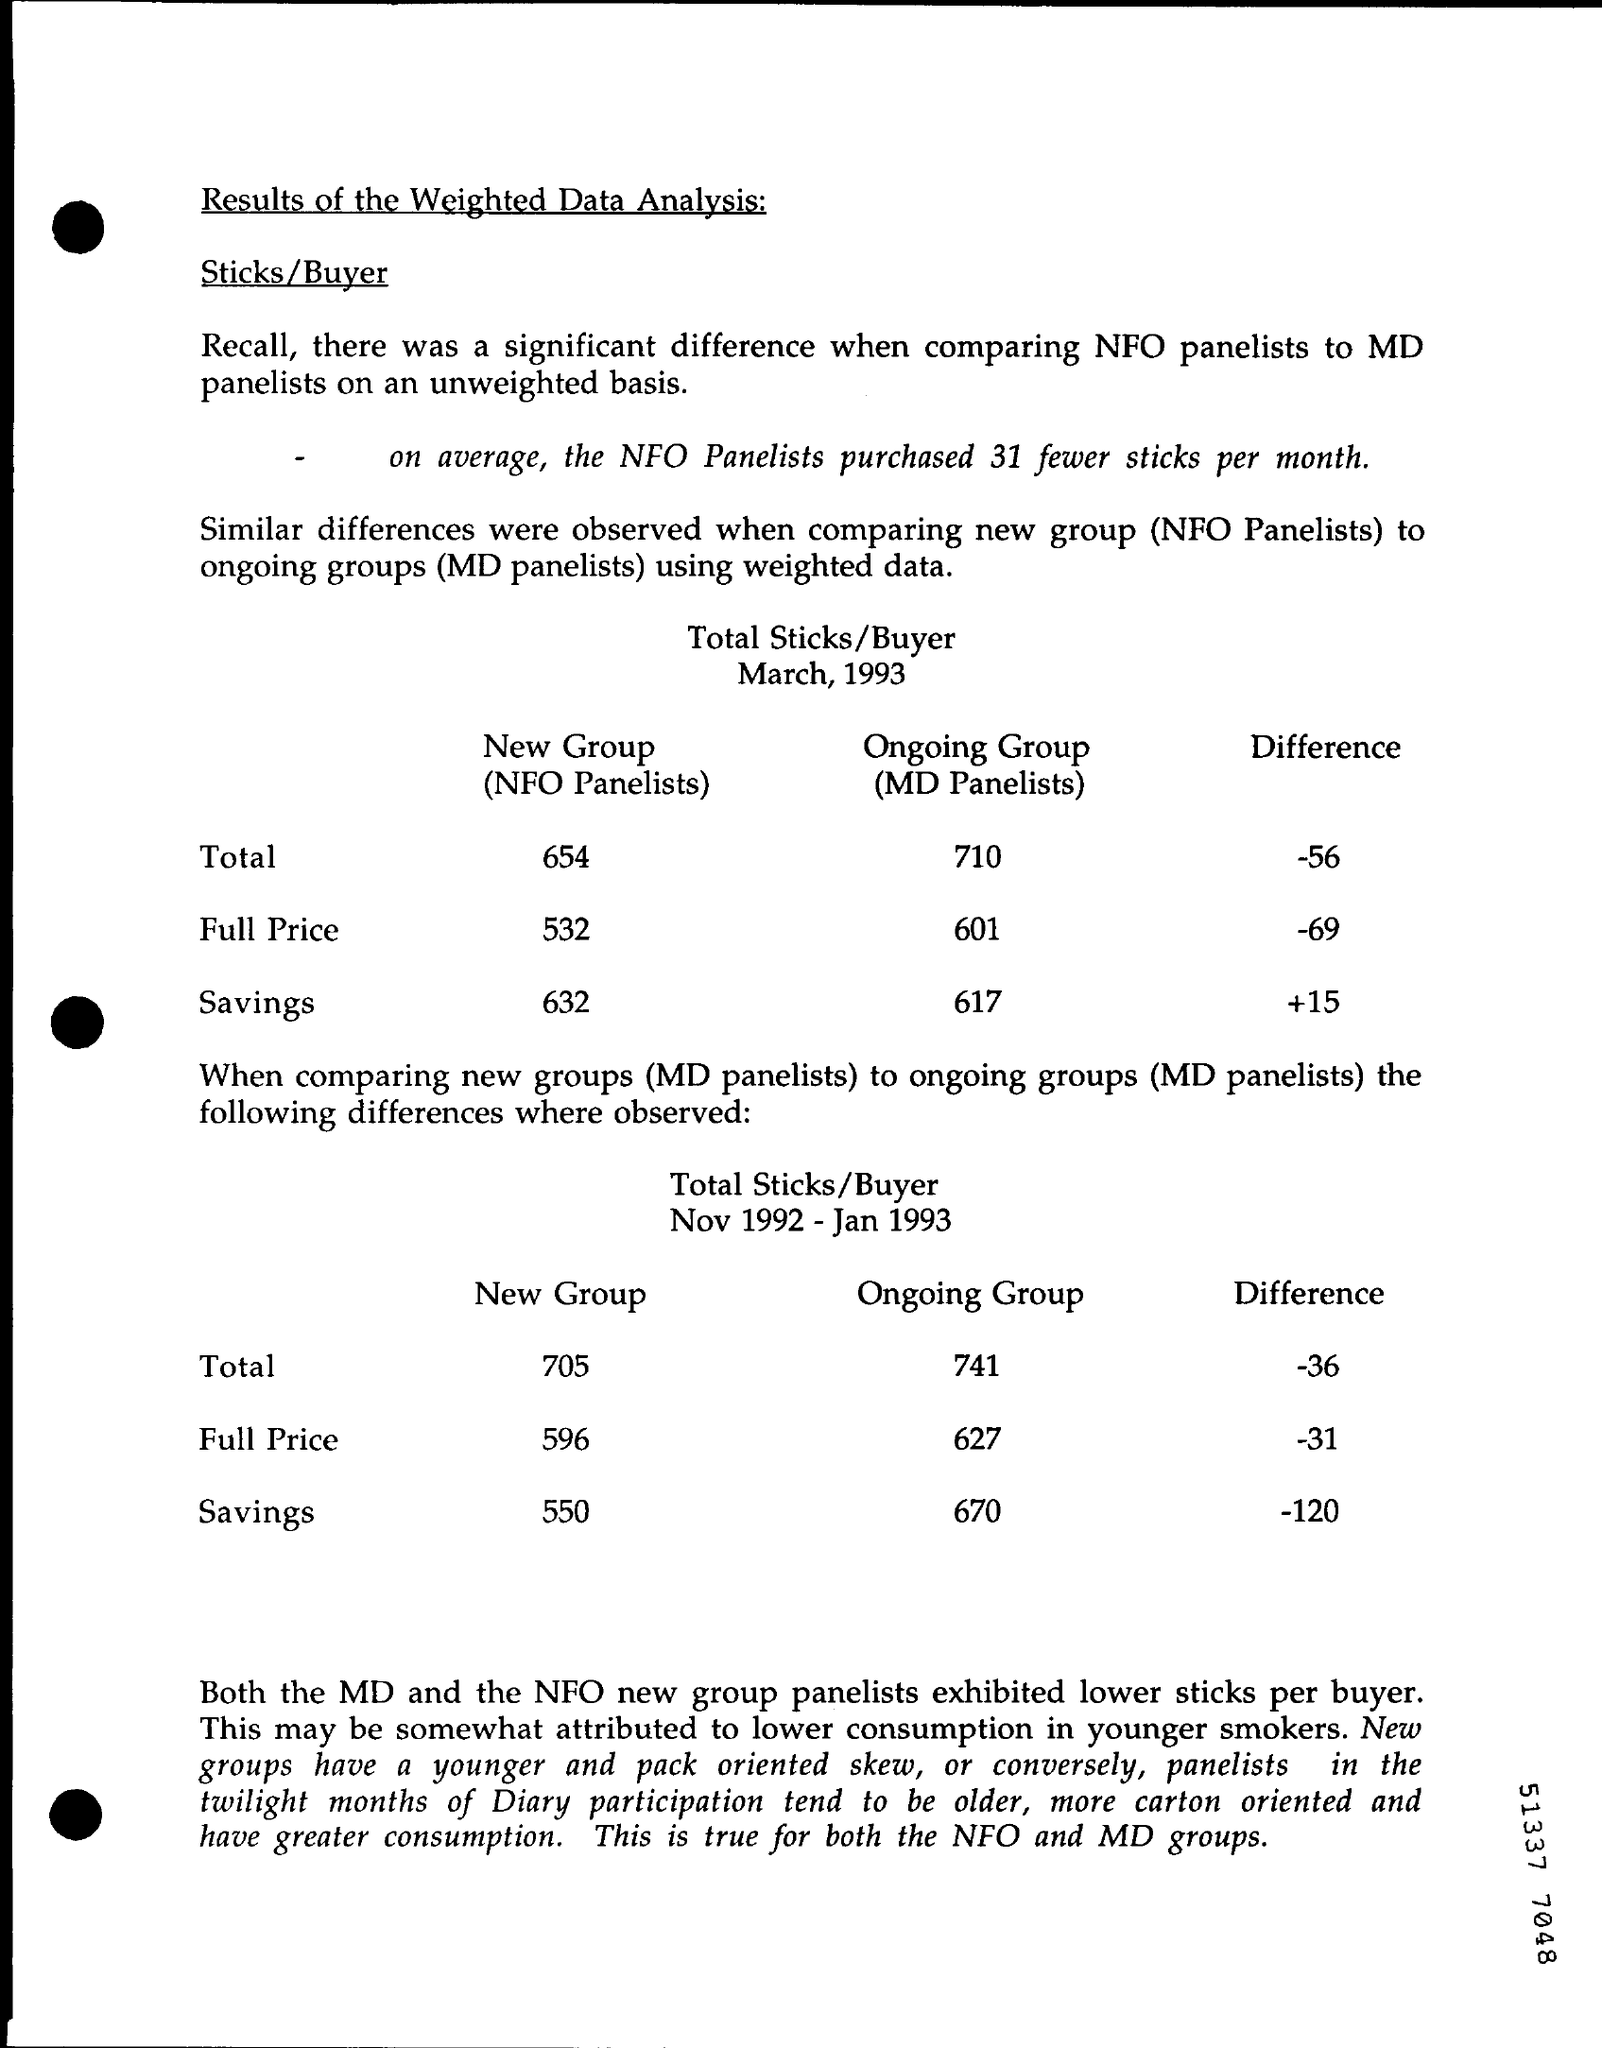On an average who many fewer sticks were purchased by nfo panelists ?
Give a very brief answer. 31. What is the total value of new group (nfo panelists) in march 1993 ?
Your answer should be very brief. 654. What is the full price of ongoing group (md panelists) in march 1993 ?
Provide a succinct answer. 601. What is the difference value in savings in march 1993 ?
Offer a very short reply. +15. What is the value of full price in the new group from nov 1992- jan 1993 ?
Your answer should be very brief. 596. What is the value of savings in the on going group from nov 1992 - jan 1993 ?
Offer a terse response. 670. What is the difference value in the full price from nov 1992 - jan 1993 ?
Ensure brevity in your answer.  -31. 